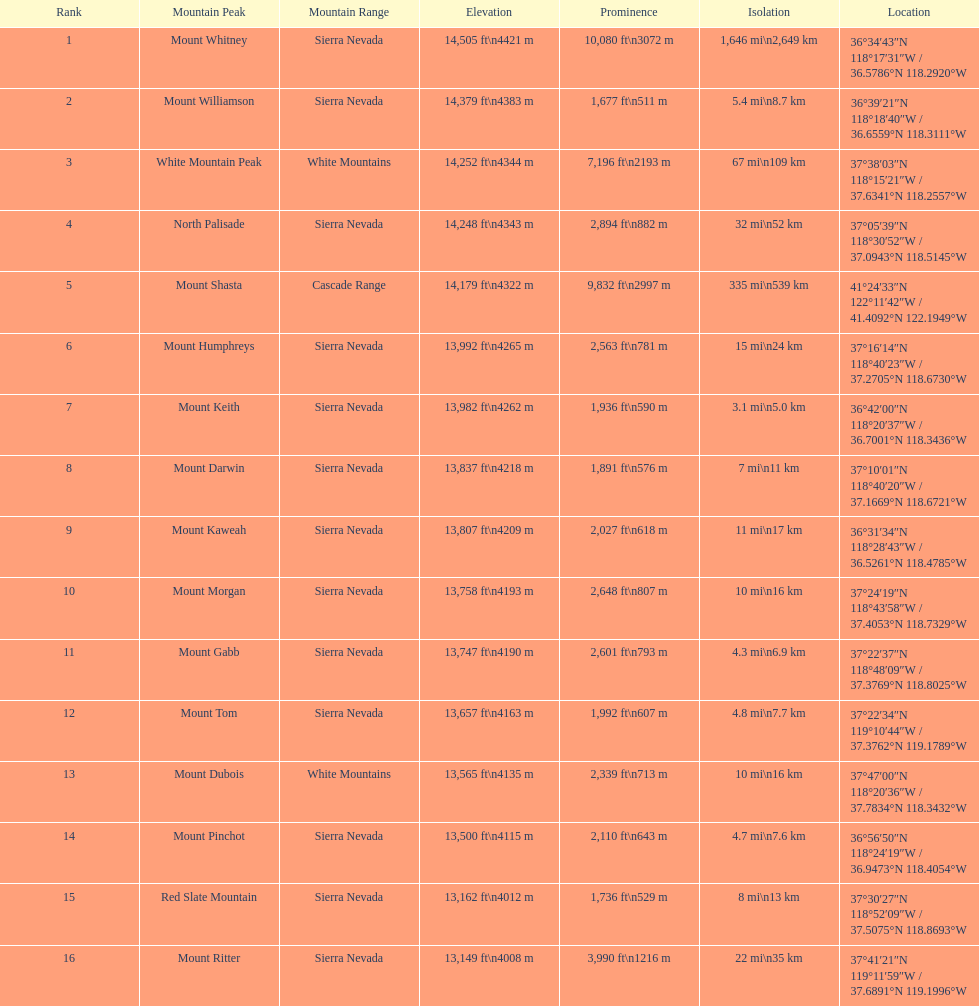In feet, what is the disparity between the highest summit and the 9th highest summit in california? 698 ft. 